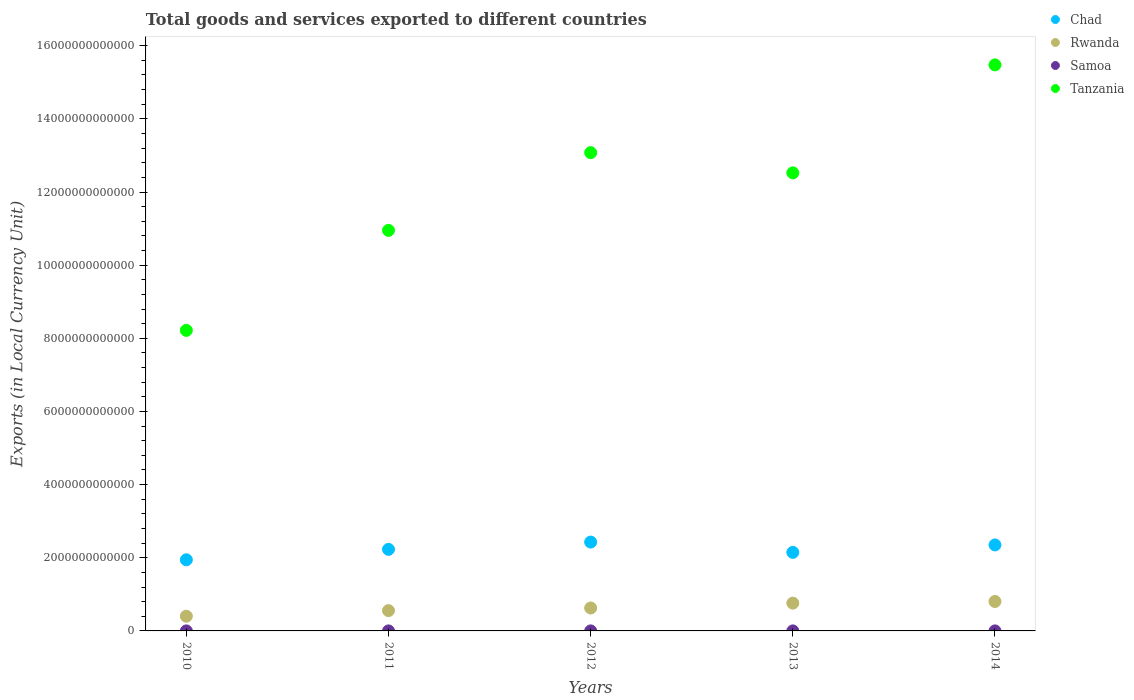What is the Amount of goods and services exports in Tanzania in 2014?
Your response must be concise. 1.55e+13. Across all years, what is the maximum Amount of goods and services exports in Rwanda?
Keep it short and to the point. 8.05e+11. Across all years, what is the minimum Amount of goods and services exports in Tanzania?
Your answer should be very brief. 8.22e+12. In which year was the Amount of goods and services exports in Rwanda minimum?
Keep it short and to the point. 2010. What is the total Amount of goods and services exports in Chad in the graph?
Provide a succinct answer. 1.11e+13. What is the difference between the Amount of goods and services exports in Rwanda in 2010 and that in 2014?
Make the answer very short. -4.03e+11. What is the difference between the Amount of goods and services exports in Chad in 2014 and the Amount of goods and services exports in Rwanda in 2010?
Provide a short and direct response. 1.95e+12. What is the average Amount of goods and services exports in Tanzania per year?
Your answer should be compact. 1.20e+13. In the year 2012, what is the difference between the Amount of goods and services exports in Tanzania and Amount of goods and services exports in Chad?
Your answer should be very brief. 1.06e+13. In how many years, is the Amount of goods and services exports in Tanzania greater than 4800000000000 LCU?
Your answer should be very brief. 5. What is the ratio of the Amount of goods and services exports in Rwanda in 2012 to that in 2014?
Provide a succinct answer. 0.78. What is the difference between the highest and the second highest Amount of goods and services exports in Chad?
Make the answer very short. 7.75e+1. What is the difference between the highest and the lowest Amount of goods and services exports in Samoa?
Give a very brief answer. 8.07e+07. In how many years, is the Amount of goods and services exports in Samoa greater than the average Amount of goods and services exports in Samoa taken over all years?
Ensure brevity in your answer.  2. Does the Amount of goods and services exports in Samoa monotonically increase over the years?
Offer a very short reply. No. Is the Amount of goods and services exports in Rwanda strictly greater than the Amount of goods and services exports in Tanzania over the years?
Make the answer very short. No. Is the Amount of goods and services exports in Chad strictly less than the Amount of goods and services exports in Tanzania over the years?
Your answer should be compact. Yes. What is the difference between two consecutive major ticks on the Y-axis?
Your answer should be compact. 2.00e+12. Does the graph contain grids?
Provide a succinct answer. No. How are the legend labels stacked?
Offer a very short reply. Vertical. What is the title of the graph?
Ensure brevity in your answer.  Total goods and services exported to different countries. Does "West Bank and Gaza" appear as one of the legend labels in the graph?
Provide a short and direct response. No. What is the label or title of the X-axis?
Offer a very short reply. Years. What is the label or title of the Y-axis?
Give a very brief answer. Exports (in Local Currency Unit). What is the Exports (in Local Currency Unit) of Chad in 2010?
Your response must be concise. 1.94e+12. What is the Exports (in Local Currency Unit) of Rwanda in 2010?
Ensure brevity in your answer.  4.02e+11. What is the Exports (in Local Currency Unit) of Samoa in 2010?
Make the answer very short. 4.77e+08. What is the Exports (in Local Currency Unit) of Tanzania in 2010?
Your answer should be compact. 8.22e+12. What is the Exports (in Local Currency Unit) of Chad in 2011?
Your response must be concise. 2.23e+12. What is the Exports (in Local Currency Unit) in Rwanda in 2011?
Your answer should be compact. 5.55e+11. What is the Exports (in Local Currency Unit) in Samoa in 2011?
Offer a very short reply. 5.07e+08. What is the Exports (in Local Currency Unit) of Tanzania in 2011?
Give a very brief answer. 1.10e+13. What is the Exports (in Local Currency Unit) of Chad in 2012?
Make the answer very short. 2.43e+12. What is the Exports (in Local Currency Unit) in Rwanda in 2012?
Your response must be concise. 6.27e+11. What is the Exports (in Local Currency Unit) of Samoa in 2012?
Offer a terse response. 5.10e+08. What is the Exports (in Local Currency Unit) of Tanzania in 2012?
Make the answer very short. 1.31e+13. What is the Exports (in Local Currency Unit) in Chad in 2013?
Provide a short and direct response. 2.15e+12. What is the Exports (in Local Currency Unit) of Rwanda in 2013?
Offer a very short reply. 7.60e+11. What is the Exports (in Local Currency Unit) in Samoa in 2013?
Provide a short and direct response. 5.58e+08. What is the Exports (in Local Currency Unit) of Tanzania in 2013?
Your answer should be compact. 1.25e+13. What is the Exports (in Local Currency Unit) of Chad in 2014?
Offer a very short reply. 2.35e+12. What is the Exports (in Local Currency Unit) of Rwanda in 2014?
Make the answer very short. 8.05e+11. What is the Exports (in Local Currency Unit) of Samoa in 2014?
Provide a short and direct response. 5.27e+08. What is the Exports (in Local Currency Unit) in Tanzania in 2014?
Your answer should be compact. 1.55e+13. Across all years, what is the maximum Exports (in Local Currency Unit) of Chad?
Your response must be concise. 2.43e+12. Across all years, what is the maximum Exports (in Local Currency Unit) of Rwanda?
Your response must be concise. 8.05e+11. Across all years, what is the maximum Exports (in Local Currency Unit) of Samoa?
Offer a terse response. 5.58e+08. Across all years, what is the maximum Exports (in Local Currency Unit) of Tanzania?
Your answer should be very brief. 1.55e+13. Across all years, what is the minimum Exports (in Local Currency Unit) in Chad?
Offer a terse response. 1.94e+12. Across all years, what is the minimum Exports (in Local Currency Unit) in Rwanda?
Give a very brief answer. 4.02e+11. Across all years, what is the minimum Exports (in Local Currency Unit) of Samoa?
Provide a succinct answer. 4.77e+08. Across all years, what is the minimum Exports (in Local Currency Unit) in Tanzania?
Make the answer very short. 8.22e+12. What is the total Exports (in Local Currency Unit) in Chad in the graph?
Provide a succinct answer. 1.11e+13. What is the total Exports (in Local Currency Unit) of Rwanda in the graph?
Ensure brevity in your answer.  3.15e+12. What is the total Exports (in Local Currency Unit) of Samoa in the graph?
Provide a succinct answer. 2.58e+09. What is the total Exports (in Local Currency Unit) of Tanzania in the graph?
Provide a succinct answer. 6.02e+13. What is the difference between the Exports (in Local Currency Unit) of Chad in 2010 and that in 2011?
Ensure brevity in your answer.  -2.85e+11. What is the difference between the Exports (in Local Currency Unit) of Rwanda in 2010 and that in 2011?
Offer a very short reply. -1.53e+11. What is the difference between the Exports (in Local Currency Unit) of Samoa in 2010 and that in 2011?
Keep it short and to the point. -3.01e+07. What is the difference between the Exports (in Local Currency Unit) of Tanzania in 2010 and that in 2011?
Offer a terse response. -2.73e+12. What is the difference between the Exports (in Local Currency Unit) of Chad in 2010 and that in 2012?
Make the answer very short. -4.84e+11. What is the difference between the Exports (in Local Currency Unit) in Rwanda in 2010 and that in 2012?
Offer a very short reply. -2.25e+11. What is the difference between the Exports (in Local Currency Unit) of Samoa in 2010 and that in 2012?
Provide a succinct answer. -3.34e+07. What is the difference between the Exports (in Local Currency Unit) of Tanzania in 2010 and that in 2012?
Offer a terse response. -4.86e+12. What is the difference between the Exports (in Local Currency Unit) in Chad in 2010 and that in 2013?
Ensure brevity in your answer.  -2.03e+11. What is the difference between the Exports (in Local Currency Unit) in Rwanda in 2010 and that in 2013?
Ensure brevity in your answer.  -3.58e+11. What is the difference between the Exports (in Local Currency Unit) of Samoa in 2010 and that in 2013?
Keep it short and to the point. -8.07e+07. What is the difference between the Exports (in Local Currency Unit) of Tanzania in 2010 and that in 2013?
Your response must be concise. -4.31e+12. What is the difference between the Exports (in Local Currency Unit) in Chad in 2010 and that in 2014?
Your answer should be compact. -4.07e+11. What is the difference between the Exports (in Local Currency Unit) of Rwanda in 2010 and that in 2014?
Offer a terse response. -4.03e+11. What is the difference between the Exports (in Local Currency Unit) of Samoa in 2010 and that in 2014?
Ensure brevity in your answer.  -5.03e+07. What is the difference between the Exports (in Local Currency Unit) of Tanzania in 2010 and that in 2014?
Offer a very short reply. -7.26e+12. What is the difference between the Exports (in Local Currency Unit) of Chad in 2011 and that in 2012?
Your response must be concise. -1.99e+11. What is the difference between the Exports (in Local Currency Unit) of Rwanda in 2011 and that in 2012?
Provide a short and direct response. -7.20e+1. What is the difference between the Exports (in Local Currency Unit) in Samoa in 2011 and that in 2012?
Keep it short and to the point. -3.29e+06. What is the difference between the Exports (in Local Currency Unit) in Tanzania in 2011 and that in 2012?
Keep it short and to the point. -2.12e+12. What is the difference between the Exports (in Local Currency Unit) in Chad in 2011 and that in 2013?
Offer a terse response. 8.26e+1. What is the difference between the Exports (in Local Currency Unit) in Rwanda in 2011 and that in 2013?
Give a very brief answer. -2.05e+11. What is the difference between the Exports (in Local Currency Unit) of Samoa in 2011 and that in 2013?
Your answer should be very brief. -5.06e+07. What is the difference between the Exports (in Local Currency Unit) in Tanzania in 2011 and that in 2013?
Keep it short and to the point. -1.57e+12. What is the difference between the Exports (in Local Currency Unit) in Chad in 2011 and that in 2014?
Offer a very short reply. -1.21e+11. What is the difference between the Exports (in Local Currency Unit) of Rwanda in 2011 and that in 2014?
Give a very brief answer. -2.50e+11. What is the difference between the Exports (in Local Currency Unit) in Samoa in 2011 and that in 2014?
Provide a succinct answer. -2.02e+07. What is the difference between the Exports (in Local Currency Unit) in Tanzania in 2011 and that in 2014?
Your answer should be very brief. -4.53e+12. What is the difference between the Exports (in Local Currency Unit) of Chad in 2012 and that in 2013?
Your answer should be very brief. 2.82e+11. What is the difference between the Exports (in Local Currency Unit) of Rwanda in 2012 and that in 2013?
Offer a very short reply. -1.33e+11. What is the difference between the Exports (in Local Currency Unit) in Samoa in 2012 and that in 2013?
Offer a very short reply. -4.74e+07. What is the difference between the Exports (in Local Currency Unit) in Tanzania in 2012 and that in 2013?
Your answer should be compact. 5.52e+11. What is the difference between the Exports (in Local Currency Unit) in Chad in 2012 and that in 2014?
Your response must be concise. 7.75e+1. What is the difference between the Exports (in Local Currency Unit) in Rwanda in 2012 and that in 2014?
Ensure brevity in your answer.  -1.78e+11. What is the difference between the Exports (in Local Currency Unit) of Samoa in 2012 and that in 2014?
Your answer should be compact. -1.69e+07. What is the difference between the Exports (in Local Currency Unit) of Tanzania in 2012 and that in 2014?
Your response must be concise. -2.40e+12. What is the difference between the Exports (in Local Currency Unit) in Chad in 2013 and that in 2014?
Provide a short and direct response. -2.04e+11. What is the difference between the Exports (in Local Currency Unit) in Rwanda in 2013 and that in 2014?
Offer a very short reply. -4.50e+1. What is the difference between the Exports (in Local Currency Unit) of Samoa in 2013 and that in 2014?
Offer a terse response. 3.05e+07. What is the difference between the Exports (in Local Currency Unit) of Tanzania in 2013 and that in 2014?
Offer a terse response. -2.95e+12. What is the difference between the Exports (in Local Currency Unit) of Chad in 2010 and the Exports (in Local Currency Unit) of Rwanda in 2011?
Ensure brevity in your answer.  1.39e+12. What is the difference between the Exports (in Local Currency Unit) in Chad in 2010 and the Exports (in Local Currency Unit) in Samoa in 2011?
Keep it short and to the point. 1.94e+12. What is the difference between the Exports (in Local Currency Unit) of Chad in 2010 and the Exports (in Local Currency Unit) of Tanzania in 2011?
Ensure brevity in your answer.  -9.01e+12. What is the difference between the Exports (in Local Currency Unit) in Rwanda in 2010 and the Exports (in Local Currency Unit) in Samoa in 2011?
Your answer should be very brief. 4.01e+11. What is the difference between the Exports (in Local Currency Unit) of Rwanda in 2010 and the Exports (in Local Currency Unit) of Tanzania in 2011?
Ensure brevity in your answer.  -1.05e+13. What is the difference between the Exports (in Local Currency Unit) in Samoa in 2010 and the Exports (in Local Currency Unit) in Tanzania in 2011?
Provide a succinct answer. -1.10e+13. What is the difference between the Exports (in Local Currency Unit) of Chad in 2010 and the Exports (in Local Currency Unit) of Rwanda in 2012?
Your answer should be compact. 1.32e+12. What is the difference between the Exports (in Local Currency Unit) in Chad in 2010 and the Exports (in Local Currency Unit) in Samoa in 2012?
Give a very brief answer. 1.94e+12. What is the difference between the Exports (in Local Currency Unit) in Chad in 2010 and the Exports (in Local Currency Unit) in Tanzania in 2012?
Provide a succinct answer. -1.11e+13. What is the difference between the Exports (in Local Currency Unit) in Rwanda in 2010 and the Exports (in Local Currency Unit) in Samoa in 2012?
Provide a short and direct response. 4.01e+11. What is the difference between the Exports (in Local Currency Unit) of Rwanda in 2010 and the Exports (in Local Currency Unit) of Tanzania in 2012?
Give a very brief answer. -1.27e+13. What is the difference between the Exports (in Local Currency Unit) in Samoa in 2010 and the Exports (in Local Currency Unit) in Tanzania in 2012?
Offer a terse response. -1.31e+13. What is the difference between the Exports (in Local Currency Unit) in Chad in 2010 and the Exports (in Local Currency Unit) in Rwanda in 2013?
Your answer should be compact. 1.18e+12. What is the difference between the Exports (in Local Currency Unit) in Chad in 2010 and the Exports (in Local Currency Unit) in Samoa in 2013?
Offer a terse response. 1.94e+12. What is the difference between the Exports (in Local Currency Unit) in Chad in 2010 and the Exports (in Local Currency Unit) in Tanzania in 2013?
Give a very brief answer. -1.06e+13. What is the difference between the Exports (in Local Currency Unit) of Rwanda in 2010 and the Exports (in Local Currency Unit) of Samoa in 2013?
Provide a succinct answer. 4.01e+11. What is the difference between the Exports (in Local Currency Unit) of Rwanda in 2010 and the Exports (in Local Currency Unit) of Tanzania in 2013?
Ensure brevity in your answer.  -1.21e+13. What is the difference between the Exports (in Local Currency Unit) in Samoa in 2010 and the Exports (in Local Currency Unit) in Tanzania in 2013?
Offer a terse response. -1.25e+13. What is the difference between the Exports (in Local Currency Unit) in Chad in 2010 and the Exports (in Local Currency Unit) in Rwanda in 2014?
Offer a terse response. 1.14e+12. What is the difference between the Exports (in Local Currency Unit) of Chad in 2010 and the Exports (in Local Currency Unit) of Samoa in 2014?
Give a very brief answer. 1.94e+12. What is the difference between the Exports (in Local Currency Unit) of Chad in 2010 and the Exports (in Local Currency Unit) of Tanzania in 2014?
Offer a very short reply. -1.35e+13. What is the difference between the Exports (in Local Currency Unit) of Rwanda in 2010 and the Exports (in Local Currency Unit) of Samoa in 2014?
Make the answer very short. 4.01e+11. What is the difference between the Exports (in Local Currency Unit) in Rwanda in 2010 and the Exports (in Local Currency Unit) in Tanzania in 2014?
Keep it short and to the point. -1.51e+13. What is the difference between the Exports (in Local Currency Unit) in Samoa in 2010 and the Exports (in Local Currency Unit) in Tanzania in 2014?
Your answer should be compact. -1.55e+13. What is the difference between the Exports (in Local Currency Unit) of Chad in 2011 and the Exports (in Local Currency Unit) of Rwanda in 2012?
Offer a terse response. 1.60e+12. What is the difference between the Exports (in Local Currency Unit) in Chad in 2011 and the Exports (in Local Currency Unit) in Samoa in 2012?
Provide a short and direct response. 2.23e+12. What is the difference between the Exports (in Local Currency Unit) in Chad in 2011 and the Exports (in Local Currency Unit) in Tanzania in 2012?
Your answer should be very brief. -1.08e+13. What is the difference between the Exports (in Local Currency Unit) in Rwanda in 2011 and the Exports (in Local Currency Unit) in Samoa in 2012?
Make the answer very short. 5.54e+11. What is the difference between the Exports (in Local Currency Unit) in Rwanda in 2011 and the Exports (in Local Currency Unit) in Tanzania in 2012?
Your response must be concise. -1.25e+13. What is the difference between the Exports (in Local Currency Unit) in Samoa in 2011 and the Exports (in Local Currency Unit) in Tanzania in 2012?
Your response must be concise. -1.31e+13. What is the difference between the Exports (in Local Currency Unit) of Chad in 2011 and the Exports (in Local Currency Unit) of Rwanda in 2013?
Keep it short and to the point. 1.47e+12. What is the difference between the Exports (in Local Currency Unit) in Chad in 2011 and the Exports (in Local Currency Unit) in Samoa in 2013?
Keep it short and to the point. 2.23e+12. What is the difference between the Exports (in Local Currency Unit) in Chad in 2011 and the Exports (in Local Currency Unit) in Tanzania in 2013?
Keep it short and to the point. -1.03e+13. What is the difference between the Exports (in Local Currency Unit) of Rwanda in 2011 and the Exports (in Local Currency Unit) of Samoa in 2013?
Give a very brief answer. 5.54e+11. What is the difference between the Exports (in Local Currency Unit) in Rwanda in 2011 and the Exports (in Local Currency Unit) in Tanzania in 2013?
Keep it short and to the point. -1.20e+13. What is the difference between the Exports (in Local Currency Unit) in Samoa in 2011 and the Exports (in Local Currency Unit) in Tanzania in 2013?
Offer a very short reply. -1.25e+13. What is the difference between the Exports (in Local Currency Unit) of Chad in 2011 and the Exports (in Local Currency Unit) of Rwanda in 2014?
Provide a succinct answer. 1.43e+12. What is the difference between the Exports (in Local Currency Unit) of Chad in 2011 and the Exports (in Local Currency Unit) of Samoa in 2014?
Your answer should be compact. 2.23e+12. What is the difference between the Exports (in Local Currency Unit) in Chad in 2011 and the Exports (in Local Currency Unit) in Tanzania in 2014?
Your answer should be very brief. -1.32e+13. What is the difference between the Exports (in Local Currency Unit) in Rwanda in 2011 and the Exports (in Local Currency Unit) in Samoa in 2014?
Your answer should be compact. 5.54e+11. What is the difference between the Exports (in Local Currency Unit) in Rwanda in 2011 and the Exports (in Local Currency Unit) in Tanzania in 2014?
Keep it short and to the point. -1.49e+13. What is the difference between the Exports (in Local Currency Unit) in Samoa in 2011 and the Exports (in Local Currency Unit) in Tanzania in 2014?
Your answer should be compact. -1.55e+13. What is the difference between the Exports (in Local Currency Unit) of Chad in 2012 and the Exports (in Local Currency Unit) of Rwanda in 2013?
Your response must be concise. 1.67e+12. What is the difference between the Exports (in Local Currency Unit) in Chad in 2012 and the Exports (in Local Currency Unit) in Samoa in 2013?
Your answer should be very brief. 2.43e+12. What is the difference between the Exports (in Local Currency Unit) of Chad in 2012 and the Exports (in Local Currency Unit) of Tanzania in 2013?
Your response must be concise. -1.01e+13. What is the difference between the Exports (in Local Currency Unit) in Rwanda in 2012 and the Exports (in Local Currency Unit) in Samoa in 2013?
Give a very brief answer. 6.26e+11. What is the difference between the Exports (in Local Currency Unit) in Rwanda in 2012 and the Exports (in Local Currency Unit) in Tanzania in 2013?
Keep it short and to the point. -1.19e+13. What is the difference between the Exports (in Local Currency Unit) of Samoa in 2012 and the Exports (in Local Currency Unit) of Tanzania in 2013?
Keep it short and to the point. -1.25e+13. What is the difference between the Exports (in Local Currency Unit) in Chad in 2012 and the Exports (in Local Currency Unit) in Rwanda in 2014?
Offer a very short reply. 1.62e+12. What is the difference between the Exports (in Local Currency Unit) in Chad in 2012 and the Exports (in Local Currency Unit) in Samoa in 2014?
Ensure brevity in your answer.  2.43e+12. What is the difference between the Exports (in Local Currency Unit) in Chad in 2012 and the Exports (in Local Currency Unit) in Tanzania in 2014?
Your response must be concise. -1.30e+13. What is the difference between the Exports (in Local Currency Unit) in Rwanda in 2012 and the Exports (in Local Currency Unit) in Samoa in 2014?
Your answer should be very brief. 6.26e+11. What is the difference between the Exports (in Local Currency Unit) of Rwanda in 2012 and the Exports (in Local Currency Unit) of Tanzania in 2014?
Offer a terse response. -1.48e+13. What is the difference between the Exports (in Local Currency Unit) of Samoa in 2012 and the Exports (in Local Currency Unit) of Tanzania in 2014?
Provide a succinct answer. -1.55e+13. What is the difference between the Exports (in Local Currency Unit) in Chad in 2013 and the Exports (in Local Currency Unit) in Rwanda in 2014?
Keep it short and to the point. 1.34e+12. What is the difference between the Exports (in Local Currency Unit) of Chad in 2013 and the Exports (in Local Currency Unit) of Samoa in 2014?
Give a very brief answer. 2.15e+12. What is the difference between the Exports (in Local Currency Unit) of Chad in 2013 and the Exports (in Local Currency Unit) of Tanzania in 2014?
Provide a short and direct response. -1.33e+13. What is the difference between the Exports (in Local Currency Unit) in Rwanda in 2013 and the Exports (in Local Currency Unit) in Samoa in 2014?
Ensure brevity in your answer.  7.59e+11. What is the difference between the Exports (in Local Currency Unit) of Rwanda in 2013 and the Exports (in Local Currency Unit) of Tanzania in 2014?
Your answer should be compact. -1.47e+13. What is the difference between the Exports (in Local Currency Unit) of Samoa in 2013 and the Exports (in Local Currency Unit) of Tanzania in 2014?
Provide a succinct answer. -1.55e+13. What is the average Exports (in Local Currency Unit) in Chad per year?
Make the answer very short. 2.22e+12. What is the average Exports (in Local Currency Unit) of Rwanda per year?
Your answer should be compact. 6.30e+11. What is the average Exports (in Local Currency Unit) in Samoa per year?
Your answer should be compact. 5.16e+08. What is the average Exports (in Local Currency Unit) in Tanzania per year?
Make the answer very short. 1.20e+13. In the year 2010, what is the difference between the Exports (in Local Currency Unit) in Chad and Exports (in Local Currency Unit) in Rwanda?
Your response must be concise. 1.54e+12. In the year 2010, what is the difference between the Exports (in Local Currency Unit) of Chad and Exports (in Local Currency Unit) of Samoa?
Make the answer very short. 1.94e+12. In the year 2010, what is the difference between the Exports (in Local Currency Unit) in Chad and Exports (in Local Currency Unit) in Tanzania?
Give a very brief answer. -6.27e+12. In the year 2010, what is the difference between the Exports (in Local Currency Unit) in Rwanda and Exports (in Local Currency Unit) in Samoa?
Ensure brevity in your answer.  4.02e+11. In the year 2010, what is the difference between the Exports (in Local Currency Unit) of Rwanda and Exports (in Local Currency Unit) of Tanzania?
Keep it short and to the point. -7.82e+12. In the year 2010, what is the difference between the Exports (in Local Currency Unit) in Samoa and Exports (in Local Currency Unit) in Tanzania?
Keep it short and to the point. -8.22e+12. In the year 2011, what is the difference between the Exports (in Local Currency Unit) of Chad and Exports (in Local Currency Unit) of Rwanda?
Offer a terse response. 1.68e+12. In the year 2011, what is the difference between the Exports (in Local Currency Unit) of Chad and Exports (in Local Currency Unit) of Samoa?
Give a very brief answer. 2.23e+12. In the year 2011, what is the difference between the Exports (in Local Currency Unit) in Chad and Exports (in Local Currency Unit) in Tanzania?
Your response must be concise. -8.72e+12. In the year 2011, what is the difference between the Exports (in Local Currency Unit) in Rwanda and Exports (in Local Currency Unit) in Samoa?
Provide a short and direct response. 5.54e+11. In the year 2011, what is the difference between the Exports (in Local Currency Unit) of Rwanda and Exports (in Local Currency Unit) of Tanzania?
Make the answer very short. -1.04e+13. In the year 2011, what is the difference between the Exports (in Local Currency Unit) of Samoa and Exports (in Local Currency Unit) of Tanzania?
Offer a very short reply. -1.10e+13. In the year 2012, what is the difference between the Exports (in Local Currency Unit) in Chad and Exports (in Local Currency Unit) in Rwanda?
Offer a very short reply. 1.80e+12. In the year 2012, what is the difference between the Exports (in Local Currency Unit) in Chad and Exports (in Local Currency Unit) in Samoa?
Your answer should be very brief. 2.43e+12. In the year 2012, what is the difference between the Exports (in Local Currency Unit) in Chad and Exports (in Local Currency Unit) in Tanzania?
Make the answer very short. -1.06e+13. In the year 2012, what is the difference between the Exports (in Local Currency Unit) of Rwanda and Exports (in Local Currency Unit) of Samoa?
Provide a succinct answer. 6.26e+11. In the year 2012, what is the difference between the Exports (in Local Currency Unit) of Rwanda and Exports (in Local Currency Unit) of Tanzania?
Ensure brevity in your answer.  -1.24e+13. In the year 2012, what is the difference between the Exports (in Local Currency Unit) of Samoa and Exports (in Local Currency Unit) of Tanzania?
Offer a very short reply. -1.31e+13. In the year 2013, what is the difference between the Exports (in Local Currency Unit) in Chad and Exports (in Local Currency Unit) in Rwanda?
Make the answer very short. 1.39e+12. In the year 2013, what is the difference between the Exports (in Local Currency Unit) in Chad and Exports (in Local Currency Unit) in Samoa?
Your answer should be very brief. 2.15e+12. In the year 2013, what is the difference between the Exports (in Local Currency Unit) of Chad and Exports (in Local Currency Unit) of Tanzania?
Your answer should be compact. -1.04e+13. In the year 2013, what is the difference between the Exports (in Local Currency Unit) of Rwanda and Exports (in Local Currency Unit) of Samoa?
Ensure brevity in your answer.  7.59e+11. In the year 2013, what is the difference between the Exports (in Local Currency Unit) of Rwanda and Exports (in Local Currency Unit) of Tanzania?
Provide a short and direct response. -1.18e+13. In the year 2013, what is the difference between the Exports (in Local Currency Unit) in Samoa and Exports (in Local Currency Unit) in Tanzania?
Your answer should be compact. -1.25e+13. In the year 2014, what is the difference between the Exports (in Local Currency Unit) of Chad and Exports (in Local Currency Unit) of Rwanda?
Your answer should be compact. 1.55e+12. In the year 2014, what is the difference between the Exports (in Local Currency Unit) of Chad and Exports (in Local Currency Unit) of Samoa?
Give a very brief answer. 2.35e+12. In the year 2014, what is the difference between the Exports (in Local Currency Unit) in Chad and Exports (in Local Currency Unit) in Tanzania?
Your answer should be very brief. -1.31e+13. In the year 2014, what is the difference between the Exports (in Local Currency Unit) in Rwanda and Exports (in Local Currency Unit) in Samoa?
Give a very brief answer. 8.04e+11. In the year 2014, what is the difference between the Exports (in Local Currency Unit) in Rwanda and Exports (in Local Currency Unit) in Tanzania?
Give a very brief answer. -1.47e+13. In the year 2014, what is the difference between the Exports (in Local Currency Unit) of Samoa and Exports (in Local Currency Unit) of Tanzania?
Provide a short and direct response. -1.55e+13. What is the ratio of the Exports (in Local Currency Unit) of Chad in 2010 to that in 2011?
Your response must be concise. 0.87. What is the ratio of the Exports (in Local Currency Unit) of Rwanda in 2010 to that in 2011?
Ensure brevity in your answer.  0.72. What is the ratio of the Exports (in Local Currency Unit) in Samoa in 2010 to that in 2011?
Give a very brief answer. 0.94. What is the ratio of the Exports (in Local Currency Unit) of Tanzania in 2010 to that in 2011?
Provide a succinct answer. 0.75. What is the ratio of the Exports (in Local Currency Unit) in Chad in 2010 to that in 2012?
Provide a short and direct response. 0.8. What is the ratio of the Exports (in Local Currency Unit) in Rwanda in 2010 to that in 2012?
Give a very brief answer. 0.64. What is the ratio of the Exports (in Local Currency Unit) in Samoa in 2010 to that in 2012?
Ensure brevity in your answer.  0.93. What is the ratio of the Exports (in Local Currency Unit) of Tanzania in 2010 to that in 2012?
Your answer should be very brief. 0.63. What is the ratio of the Exports (in Local Currency Unit) of Chad in 2010 to that in 2013?
Ensure brevity in your answer.  0.91. What is the ratio of the Exports (in Local Currency Unit) in Rwanda in 2010 to that in 2013?
Make the answer very short. 0.53. What is the ratio of the Exports (in Local Currency Unit) in Samoa in 2010 to that in 2013?
Your answer should be compact. 0.86. What is the ratio of the Exports (in Local Currency Unit) of Tanzania in 2010 to that in 2013?
Offer a very short reply. 0.66. What is the ratio of the Exports (in Local Currency Unit) in Chad in 2010 to that in 2014?
Your response must be concise. 0.83. What is the ratio of the Exports (in Local Currency Unit) of Rwanda in 2010 to that in 2014?
Your answer should be compact. 0.5. What is the ratio of the Exports (in Local Currency Unit) of Samoa in 2010 to that in 2014?
Offer a terse response. 0.9. What is the ratio of the Exports (in Local Currency Unit) of Tanzania in 2010 to that in 2014?
Make the answer very short. 0.53. What is the ratio of the Exports (in Local Currency Unit) in Chad in 2011 to that in 2012?
Ensure brevity in your answer.  0.92. What is the ratio of the Exports (in Local Currency Unit) of Rwanda in 2011 to that in 2012?
Give a very brief answer. 0.89. What is the ratio of the Exports (in Local Currency Unit) in Tanzania in 2011 to that in 2012?
Your answer should be very brief. 0.84. What is the ratio of the Exports (in Local Currency Unit) of Rwanda in 2011 to that in 2013?
Keep it short and to the point. 0.73. What is the ratio of the Exports (in Local Currency Unit) in Samoa in 2011 to that in 2013?
Make the answer very short. 0.91. What is the ratio of the Exports (in Local Currency Unit) in Tanzania in 2011 to that in 2013?
Make the answer very short. 0.87. What is the ratio of the Exports (in Local Currency Unit) of Chad in 2011 to that in 2014?
Offer a terse response. 0.95. What is the ratio of the Exports (in Local Currency Unit) in Rwanda in 2011 to that in 2014?
Make the answer very short. 0.69. What is the ratio of the Exports (in Local Currency Unit) of Samoa in 2011 to that in 2014?
Provide a short and direct response. 0.96. What is the ratio of the Exports (in Local Currency Unit) of Tanzania in 2011 to that in 2014?
Keep it short and to the point. 0.71. What is the ratio of the Exports (in Local Currency Unit) in Chad in 2012 to that in 2013?
Your answer should be very brief. 1.13. What is the ratio of the Exports (in Local Currency Unit) in Rwanda in 2012 to that in 2013?
Keep it short and to the point. 0.82. What is the ratio of the Exports (in Local Currency Unit) in Samoa in 2012 to that in 2013?
Make the answer very short. 0.92. What is the ratio of the Exports (in Local Currency Unit) in Tanzania in 2012 to that in 2013?
Your answer should be compact. 1.04. What is the ratio of the Exports (in Local Currency Unit) in Chad in 2012 to that in 2014?
Your answer should be very brief. 1.03. What is the ratio of the Exports (in Local Currency Unit) of Rwanda in 2012 to that in 2014?
Offer a very short reply. 0.78. What is the ratio of the Exports (in Local Currency Unit) in Tanzania in 2012 to that in 2014?
Your answer should be compact. 0.84. What is the ratio of the Exports (in Local Currency Unit) of Chad in 2013 to that in 2014?
Give a very brief answer. 0.91. What is the ratio of the Exports (in Local Currency Unit) of Rwanda in 2013 to that in 2014?
Keep it short and to the point. 0.94. What is the ratio of the Exports (in Local Currency Unit) in Samoa in 2013 to that in 2014?
Offer a very short reply. 1.06. What is the ratio of the Exports (in Local Currency Unit) of Tanzania in 2013 to that in 2014?
Offer a terse response. 0.81. What is the difference between the highest and the second highest Exports (in Local Currency Unit) in Chad?
Your answer should be very brief. 7.75e+1. What is the difference between the highest and the second highest Exports (in Local Currency Unit) of Rwanda?
Offer a very short reply. 4.50e+1. What is the difference between the highest and the second highest Exports (in Local Currency Unit) in Samoa?
Provide a short and direct response. 3.05e+07. What is the difference between the highest and the second highest Exports (in Local Currency Unit) in Tanzania?
Keep it short and to the point. 2.40e+12. What is the difference between the highest and the lowest Exports (in Local Currency Unit) in Chad?
Make the answer very short. 4.84e+11. What is the difference between the highest and the lowest Exports (in Local Currency Unit) in Rwanda?
Your answer should be very brief. 4.03e+11. What is the difference between the highest and the lowest Exports (in Local Currency Unit) in Samoa?
Keep it short and to the point. 8.07e+07. What is the difference between the highest and the lowest Exports (in Local Currency Unit) in Tanzania?
Your response must be concise. 7.26e+12. 